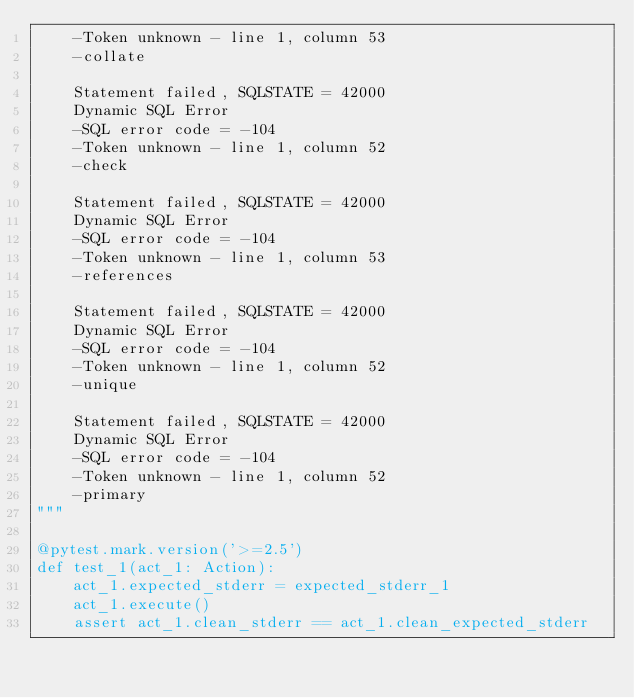Convert code to text. <code><loc_0><loc_0><loc_500><loc_500><_Python_>    -Token unknown - line 1, column 53
    -collate

    Statement failed, SQLSTATE = 42000
    Dynamic SQL Error
    -SQL error code = -104
    -Token unknown - line 1, column 52
    -check

    Statement failed, SQLSTATE = 42000
    Dynamic SQL Error
    -SQL error code = -104
    -Token unknown - line 1, column 53
    -references

    Statement failed, SQLSTATE = 42000
    Dynamic SQL Error
    -SQL error code = -104
    -Token unknown - line 1, column 52
    -unique

    Statement failed, SQLSTATE = 42000
    Dynamic SQL Error
    -SQL error code = -104
    -Token unknown - line 1, column 52
    -primary
"""

@pytest.mark.version('>=2.5')
def test_1(act_1: Action):
    act_1.expected_stderr = expected_stderr_1
    act_1.execute()
    assert act_1.clean_stderr == act_1.clean_expected_stderr

</code> 